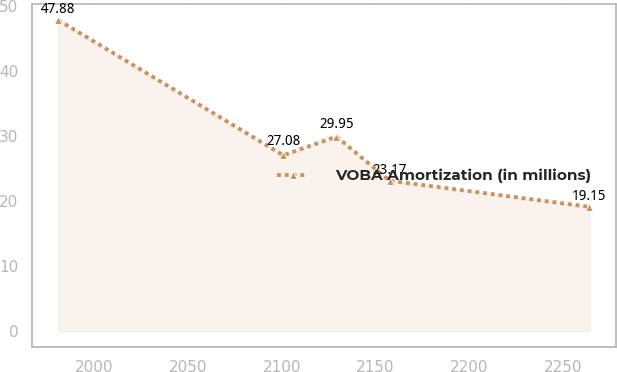Convert chart. <chart><loc_0><loc_0><loc_500><loc_500><line_chart><ecel><fcel>VOBA Amortization (in millions)<nl><fcel>1980.85<fcel>47.88<nl><fcel>2100.84<fcel>27.08<nl><fcel>2129.16<fcel>29.95<nl><fcel>2157.48<fcel>23.17<nl><fcel>2264.06<fcel>19.15<nl></chart> 